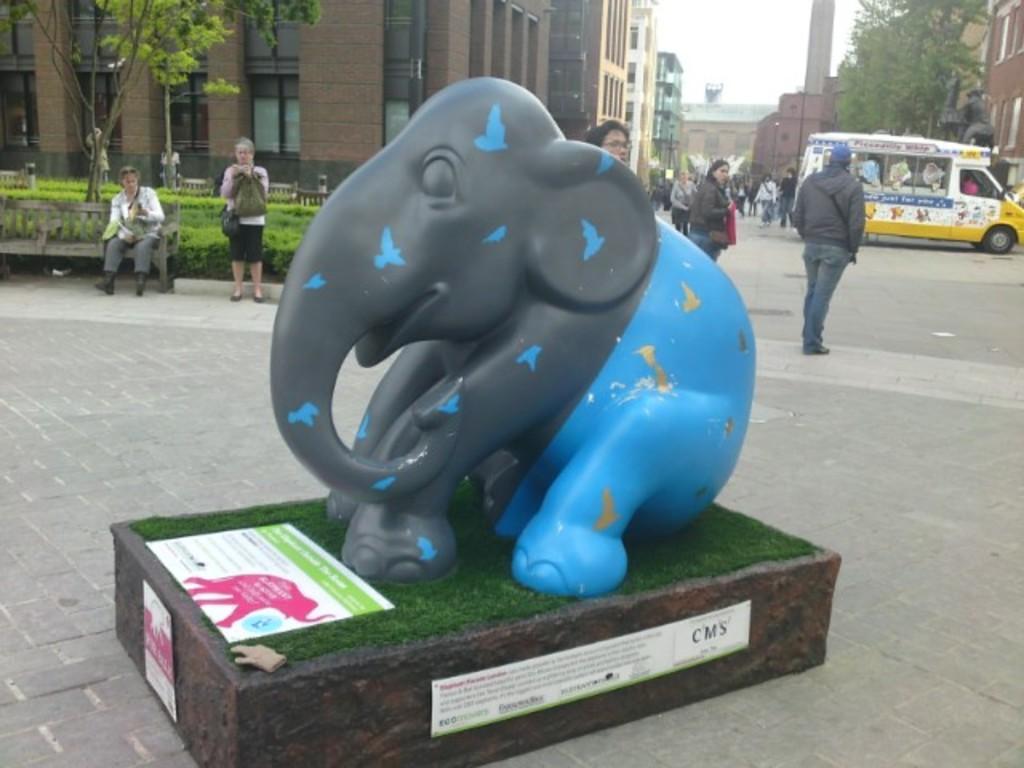Can you describe this image briefly? In the center of the image we can see a statue, grass, posters. In the background of the image we can see the road, grass, trees, buildings, windows, vehicle, statute and some people are standing. On the left side of the image we can see a person is sitting on a bench and a lady is standing and carrying a bag. At the top of the image we can see the sky. 